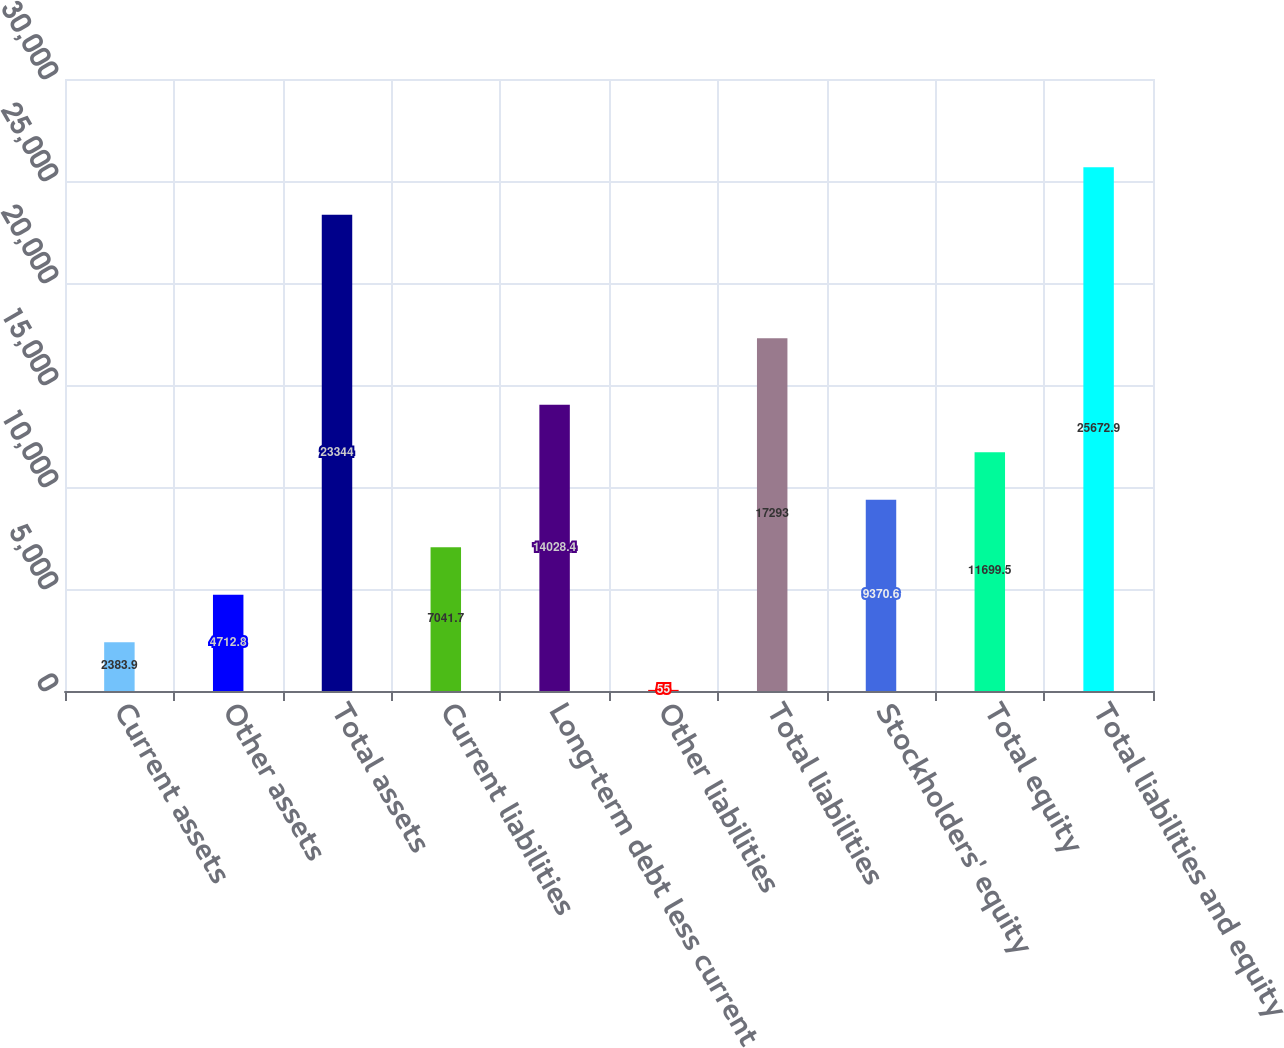<chart> <loc_0><loc_0><loc_500><loc_500><bar_chart><fcel>Current assets<fcel>Other assets<fcel>Total assets<fcel>Current liabilities<fcel>Long-term debt less current<fcel>Other liabilities<fcel>Total liabilities<fcel>Stockholders' equity<fcel>Total equity<fcel>Total liabilities and equity<nl><fcel>2383.9<fcel>4712.8<fcel>23344<fcel>7041.7<fcel>14028.4<fcel>55<fcel>17293<fcel>9370.6<fcel>11699.5<fcel>25672.9<nl></chart> 